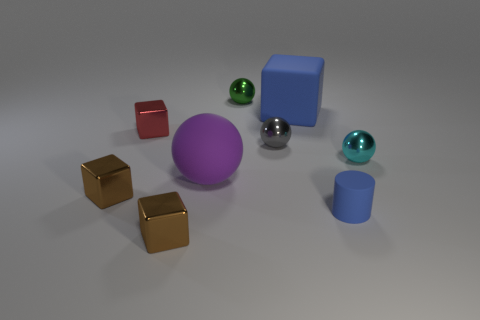Subtract all red spheres. Subtract all blue cubes. How many spheres are left? 4 Add 1 tiny gray metal objects. How many objects exist? 10 Subtract all balls. How many objects are left? 5 Add 5 small matte cylinders. How many small matte cylinders are left? 6 Add 4 tiny blue things. How many tiny blue things exist? 5 Subtract 0 brown cylinders. How many objects are left? 9 Subtract all large gray metal things. Subtract all tiny balls. How many objects are left? 6 